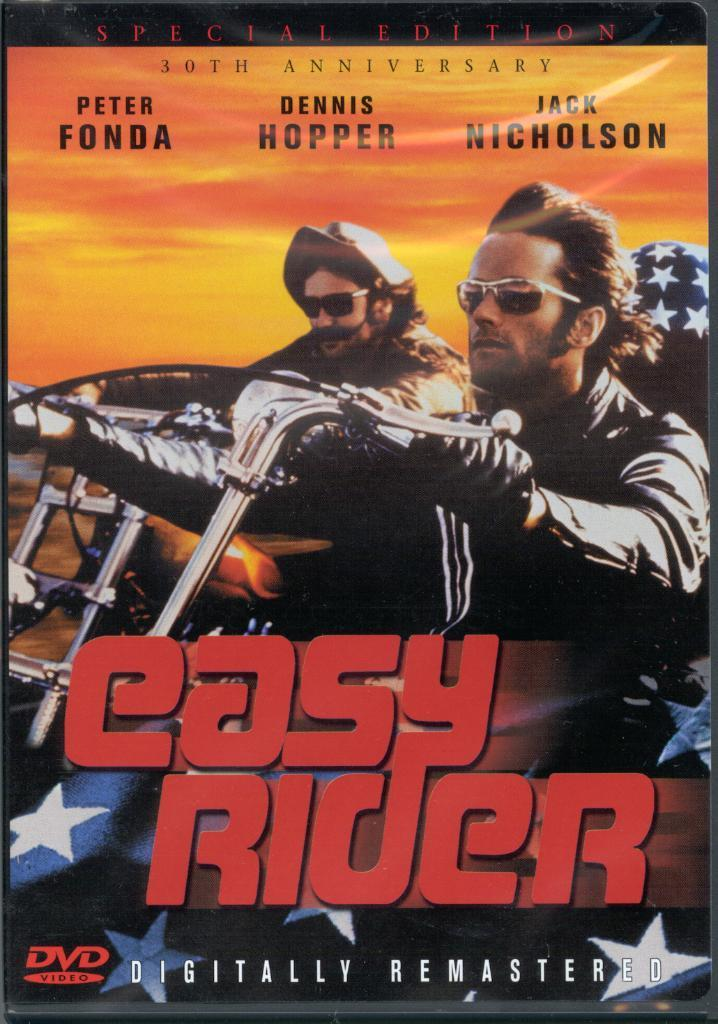Provide a one-sentence caption for the provided image. A DVD cover for Easy Rider features two men on motorcycles. 